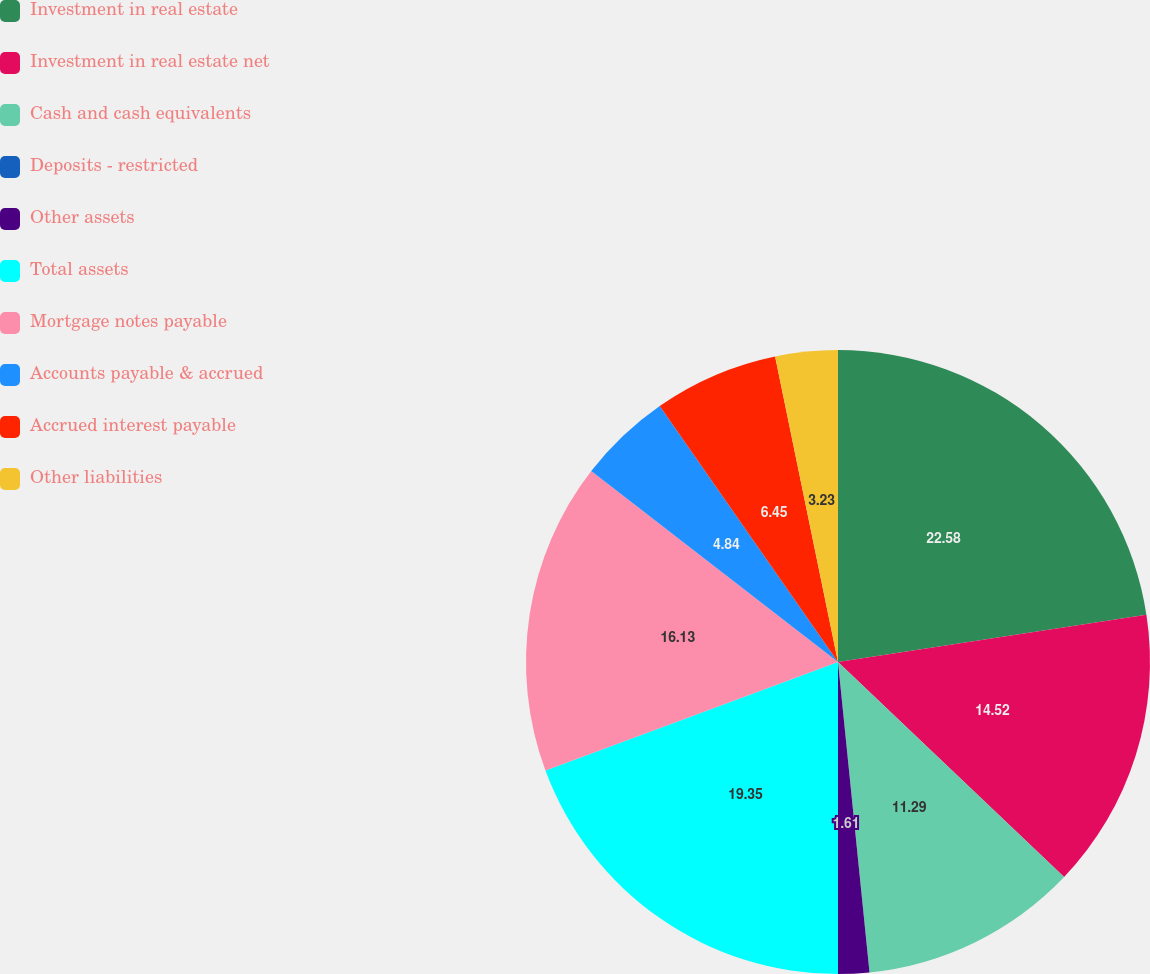Convert chart. <chart><loc_0><loc_0><loc_500><loc_500><pie_chart><fcel>Investment in real estate<fcel>Investment in real estate net<fcel>Cash and cash equivalents<fcel>Deposits - restricted<fcel>Other assets<fcel>Total assets<fcel>Mortgage notes payable<fcel>Accounts payable & accrued<fcel>Accrued interest payable<fcel>Other liabilities<nl><fcel>22.58%<fcel>14.52%<fcel>11.29%<fcel>0.0%<fcel>1.61%<fcel>19.35%<fcel>16.13%<fcel>4.84%<fcel>6.45%<fcel>3.23%<nl></chart> 